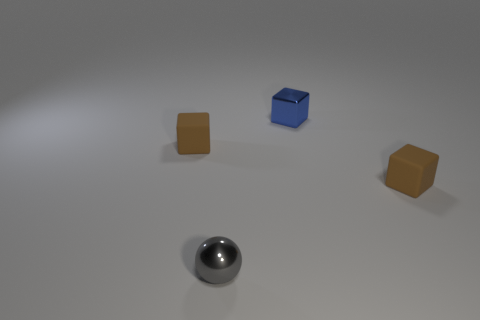Add 4 gray spheres. How many objects exist? 8 Subtract all spheres. How many objects are left? 3 Subtract all gray things. Subtract all tiny gray shiny balls. How many objects are left? 2 Add 1 small matte things. How many small matte things are left? 3 Add 1 tiny purple metallic cylinders. How many tiny purple metallic cylinders exist? 1 Subtract 0 red cylinders. How many objects are left? 4 